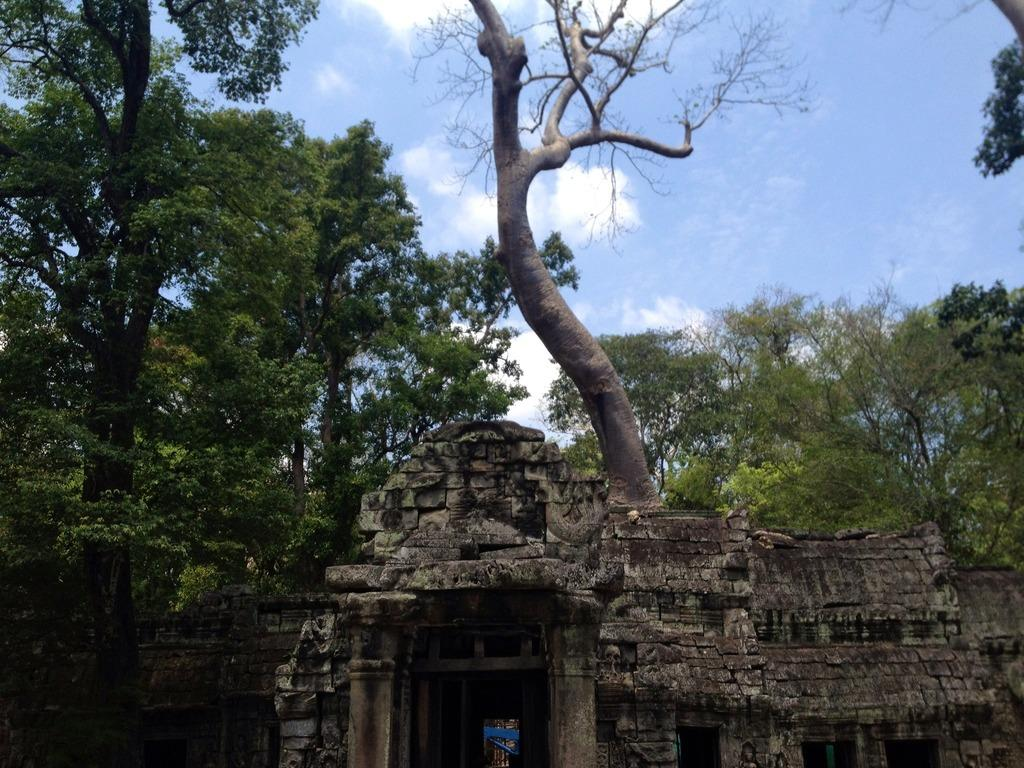What type of structure is depicted in the image? The image appears to be a fort. What material is the fort primarily made of? The fort is made up of rocks. What architectural features can be seen at the front of the fort? There are pillars in the front of the fort. What can be seen in the background of the fort? There are many trees in the background of the fort. What is visible at the top of the image? The sky is visible at the top of the image. What type of acoustics can be heard inside the fort in the image? There is no information about the acoustics inside the fort in the image, as it only shows the exterior of the structure. 